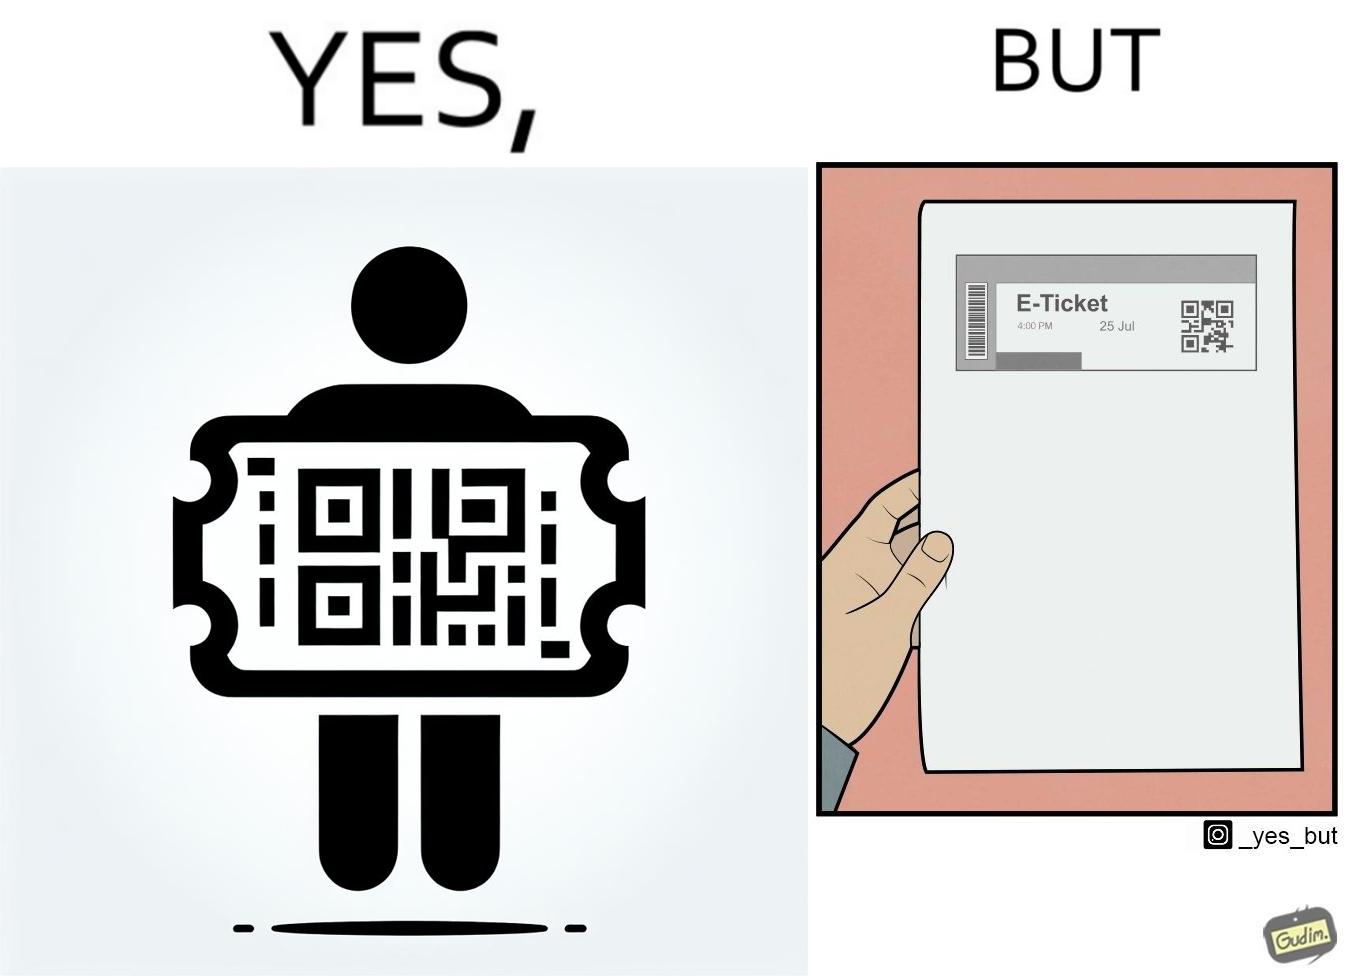Why is this image considered satirical? The images are ironic since even though e-tickets are provided to save resources like paper, people choose to print out e-tickets on large sheets of paper which leads to more wastage 